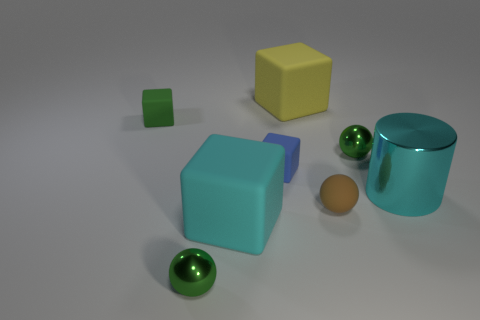There is a large object that is in front of the cyan metal object; is it the same color as the large metallic object?
Make the answer very short. Yes. How big is the matte thing that is both on the left side of the rubber ball and on the right side of the tiny blue thing?
Provide a succinct answer. Large. What number of small things are red matte objects or yellow blocks?
Make the answer very short. 0. What shape is the small green metal object that is on the left side of the large yellow rubber object?
Provide a succinct answer. Sphere. What number of small green cubes are there?
Ensure brevity in your answer.  1. Are the tiny green cube and the big cyan cube made of the same material?
Make the answer very short. Yes. Are there more small green objects that are on the left side of the green block than blue rubber cubes?
Offer a very short reply. No. How many things are either cyan objects or shiny objects behind the big cyan block?
Keep it short and to the point. 3. Is the number of small metallic objects in front of the yellow rubber thing greater than the number of brown spheres behind the cyan shiny cylinder?
Offer a terse response. Yes. What is the material of the big thing that is behind the matte thing that is left of the green metal ball left of the yellow rubber thing?
Your response must be concise. Rubber. 